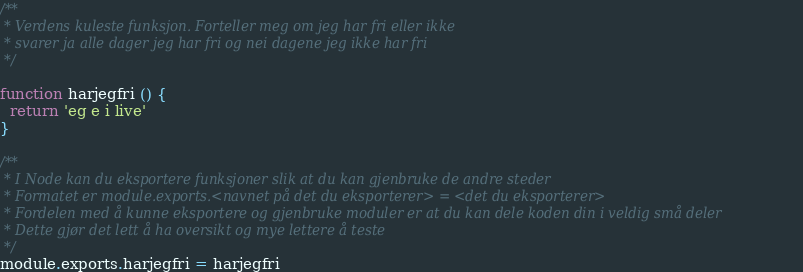Convert code to text. <code><loc_0><loc_0><loc_500><loc_500><_JavaScript_>/**
 * Verdens kuleste funksjon. Forteller meg om jeg har fri eller ikke
 * svarer ja alle dager jeg har fri og nei dagene jeg ikke har fri
 */

function harjegfri () {
  return 'eg e i live'
}

/**
 * I Node kan du eksportere funksjoner slik at du kan gjenbruke de andre steder
 * Formatet er module.exports.<navnet på det du eksporterer> = <det du eksporterer>
 * Fordelen med å kunne eksportere og gjenbruke moduler er at du kan dele koden din i veldig små deler
 * Dette gjør det lett å ha oversikt og mye lettere å teste
 */
module.exports.harjegfri = harjegfri
</code> 